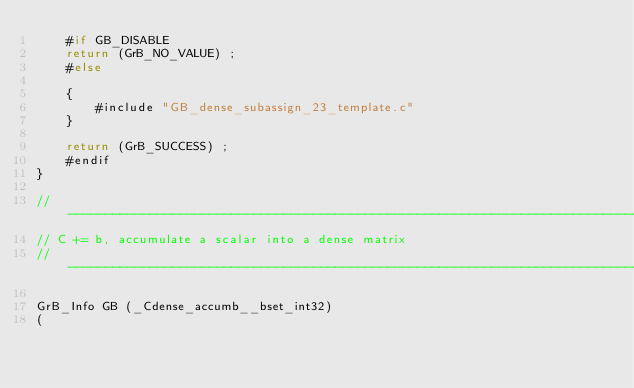Convert code to text. <code><loc_0><loc_0><loc_500><loc_500><_C_>    #if GB_DISABLE
    return (GrB_NO_VALUE) ;
    #else
    
    { 
        #include "GB_dense_subassign_23_template.c"
    }
    
    return (GrB_SUCCESS) ;
    #endif
}

//------------------------------------------------------------------------------
// C += b, accumulate a scalar into a dense matrix
//------------------------------------------------------------------------------

GrB_Info GB (_Cdense_accumb__bset_int32)
(</code> 